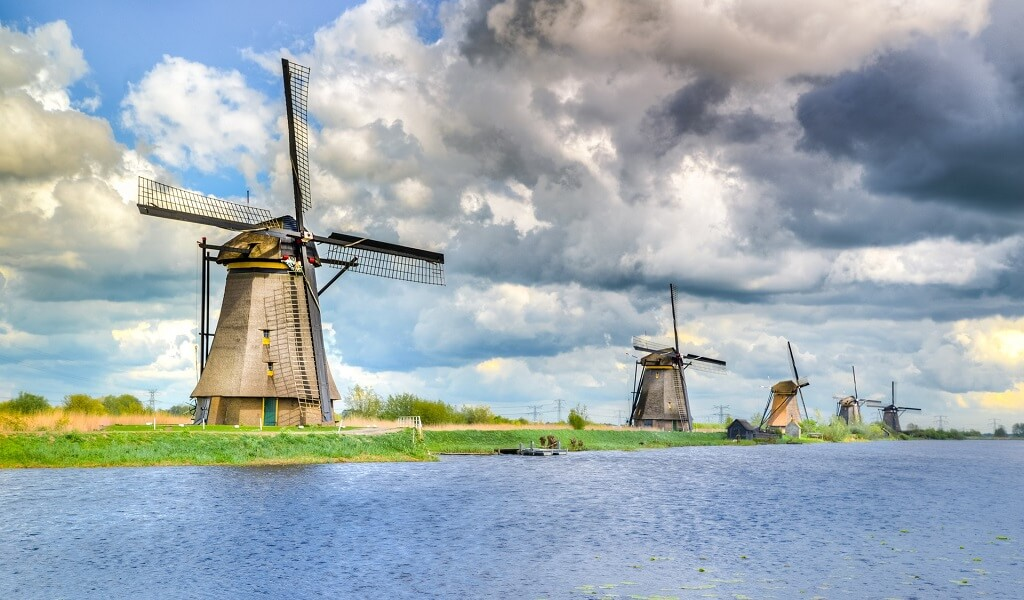How do these windmills operate and what mechanism do they use? Each windmill in Kinderdijk is equipped with a large water screw at its base, which is connected to the wind-driven rotating sails. As the sails turn with the wind, they drive the screw to lift water from the lower canals to higher watercourses. This mechanism allows for the effective displacement of water, essentially functioning as a pump. This engineering design is a remarkable example of early renewable energy usage tailored to local environmental challenges. 